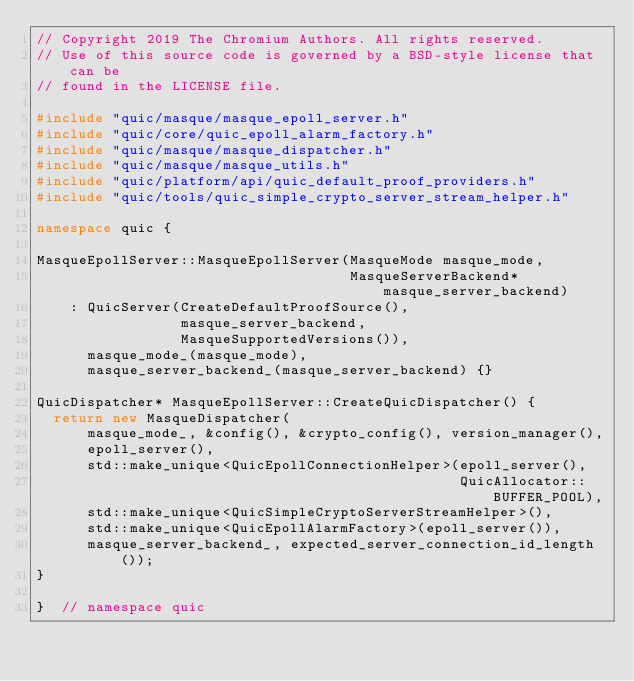<code> <loc_0><loc_0><loc_500><loc_500><_C++_>// Copyright 2019 The Chromium Authors. All rights reserved.
// Use of this source code is governed by a BSD-style license that can be
// found in the LICENSE file.

#include "quic/masque/masque_epoll_server.h"
#include "quic/core/quic_epoll_alarm_factory.h"
#include "quic/masque/masque_dispatcher.h"
#include "quic/masque/masque_utils.h"
#include "quic/platform/api/quic_default_proof_providers.h"
#include "quic/tools/quic_simple_crypto_server_stream_helper.h"

namespace quic {

MasqueEpollServer::MasqueEpollServer(MasqueMode masque_mode,
                                     MasqueServerBackend* masque_server_backend)
    : QuicServer(CreateDefaultProofSource(),
                 masque_server_backend,
                 MasqueSupportedVersions()),
      masque_mode_(masque_mode),
      masque_server_backend_(masque_server_backend) {}

QuicDispatcher* MasqueEpollServer::CreateQuicDispatcher() {
  return new MasqueDispatcher(
      masque_mode_, &config(), &crypto_config(), version_manager(),
      epoll_server(),
      std::make_unique<QuicEpollConnectionHelper>(epoll_server(),
                                                  QuicAllocator::BUFFER_POOL),
      std::make_unique<QuicSimpleCryptoServerStreamHelper>(),
      std::make_unique<QuicEpollAlarmFactory>(epoll_server()),
      masque_server_backend_, expected_server_connection_id_length());
}

}  // namespace quic
</code> 